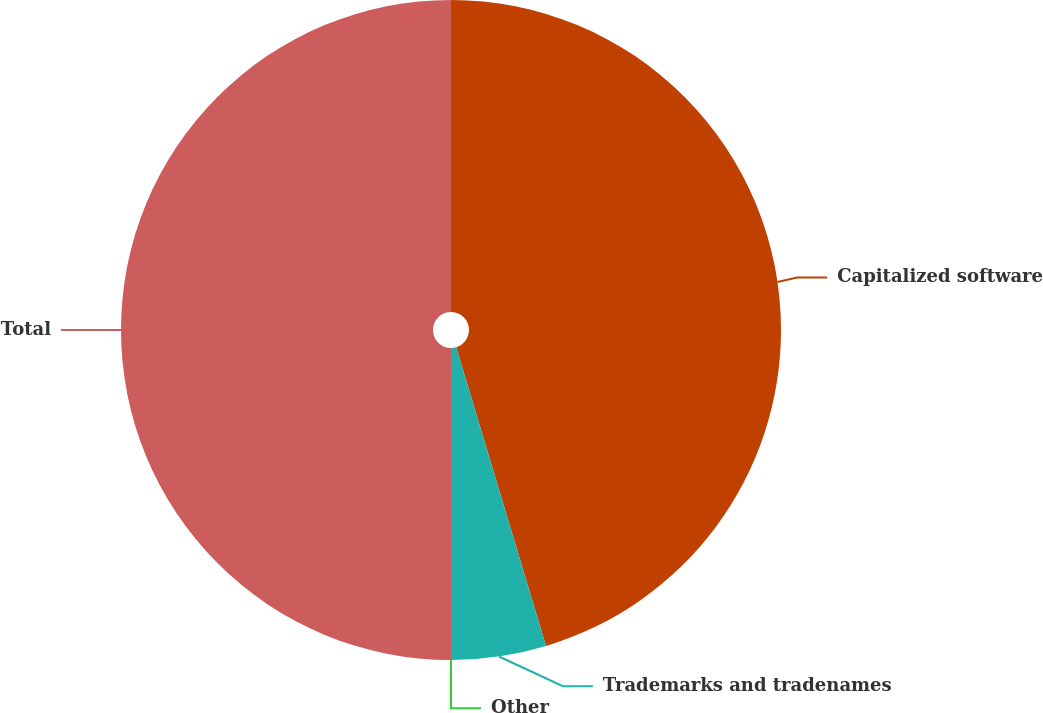<chart> <loc_0><loc_0><loc_500><loc_500><pie_chart><fcel>Capitalized software<fcel>Trademarks and tradenames<fcel>Other<fcel>Total<nl><fcel>45.35%<fcel>4.65%<fcel>0.0%<fcel>50.0%<nl></chart> 